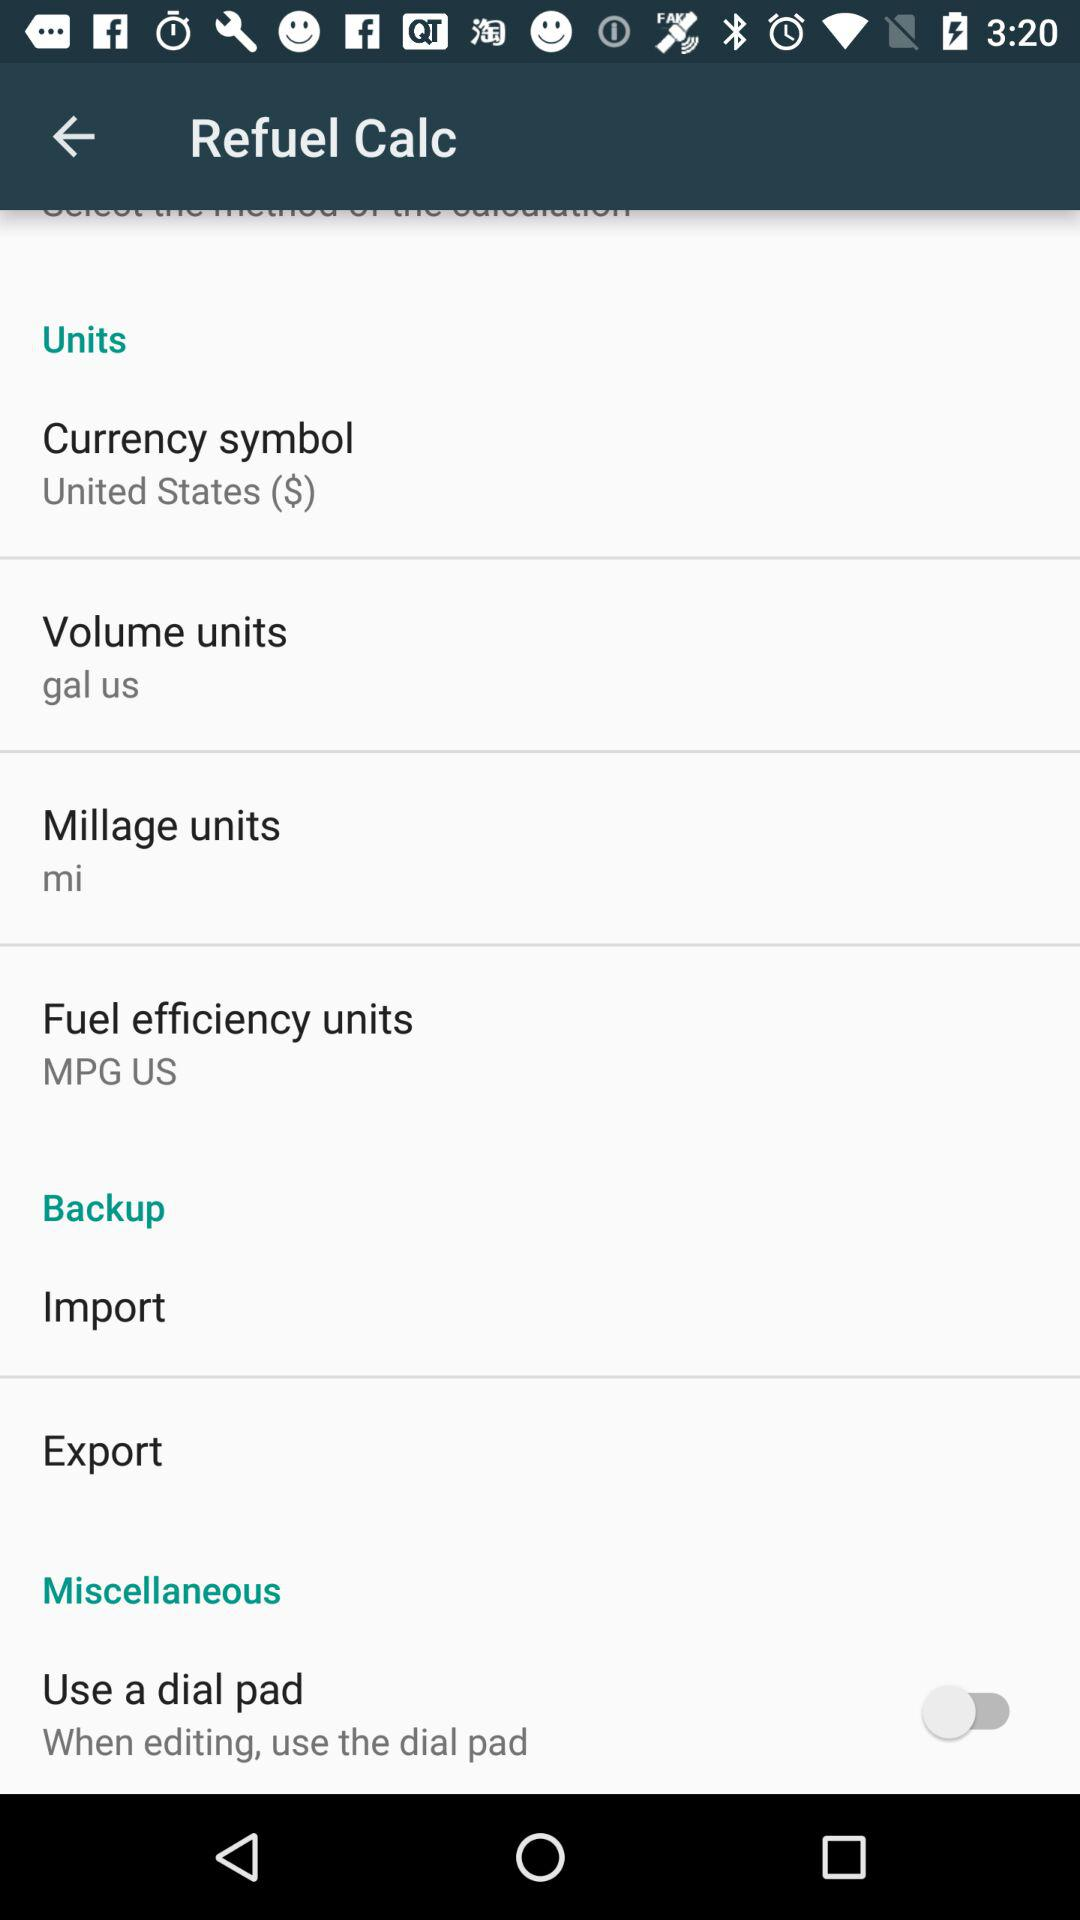What's the volume unit? The volume unit is US gallons. 